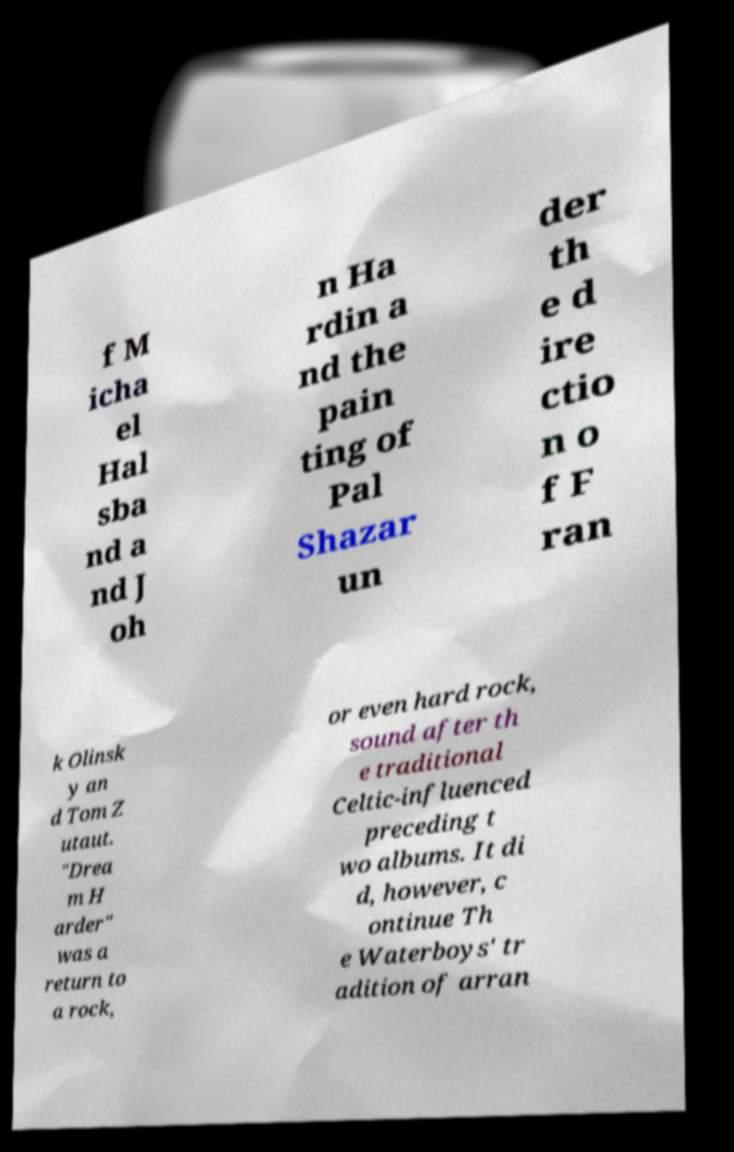Can you read and provide the text displayed in the image?This photo seems to have some interesting text. Can you extract and type it out for me? f M icha el Hal sba nd a nd J oh n Ha rdin a nd the pain ting of Pal Shazar un der th e d ire ctio n o f F ran k Olinsk y an d Tom Z utaut. "Drea m H arder" was a return to a rock, or even hard rock, sound after th e traditional Celtic-influenced preceding t wo albums. It di d, however, c ontinue Th e Waterboys' tr adition of arran 